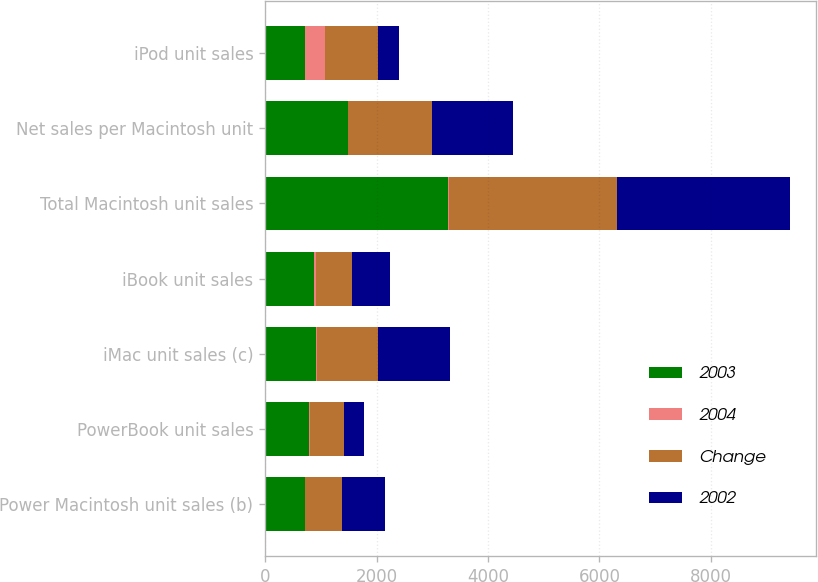Convert chart to OTSL. <chart><loc_0><loc_0><loc_500><loc_500><stacked_bar_chart><ecel><fcel>Power Macintosh unit sales (b)<fcel>PowerBook unit sales<fcel>iMac unit sales (c)<fcel>iBook unit sales<fcel>Total Macintosh unit sales<fcel>Net sales per Macintosh unit<fcel>iPod unit sales<nl><fcel>2003<fcel>709<fcel>785<fcel>916<fcel>880<fcel>3290<fcel>1496<fcel>709<nl><fcel>2004<fcel>6<fcel>30<fcel>16<fcel>36<fcel>9<fcel>0<fcel>370<nl><fcel>Change<fcel>667<fcel>604<fcel>1094<fcel>647<fcel>3012<fcel>1491<fcel>939<nl><fcel>2002<fcel>766<fcel>357<fcel>1301<fcel>677<fcel>3101<fcel>1462<fcel>381<nl></chart> 